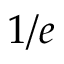Convert formula to latex. <formula><loc_0><loc_0><loc_500><loc_500>1 / e</formula> 